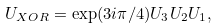<formula> <loc_0><loc_0><loc_500><loc_500>U _ { X O R } = \exp ( 3 i \pi / 4 ) U _ { 3 } U _ { 2 } U _ { 1 } ,</formula> 